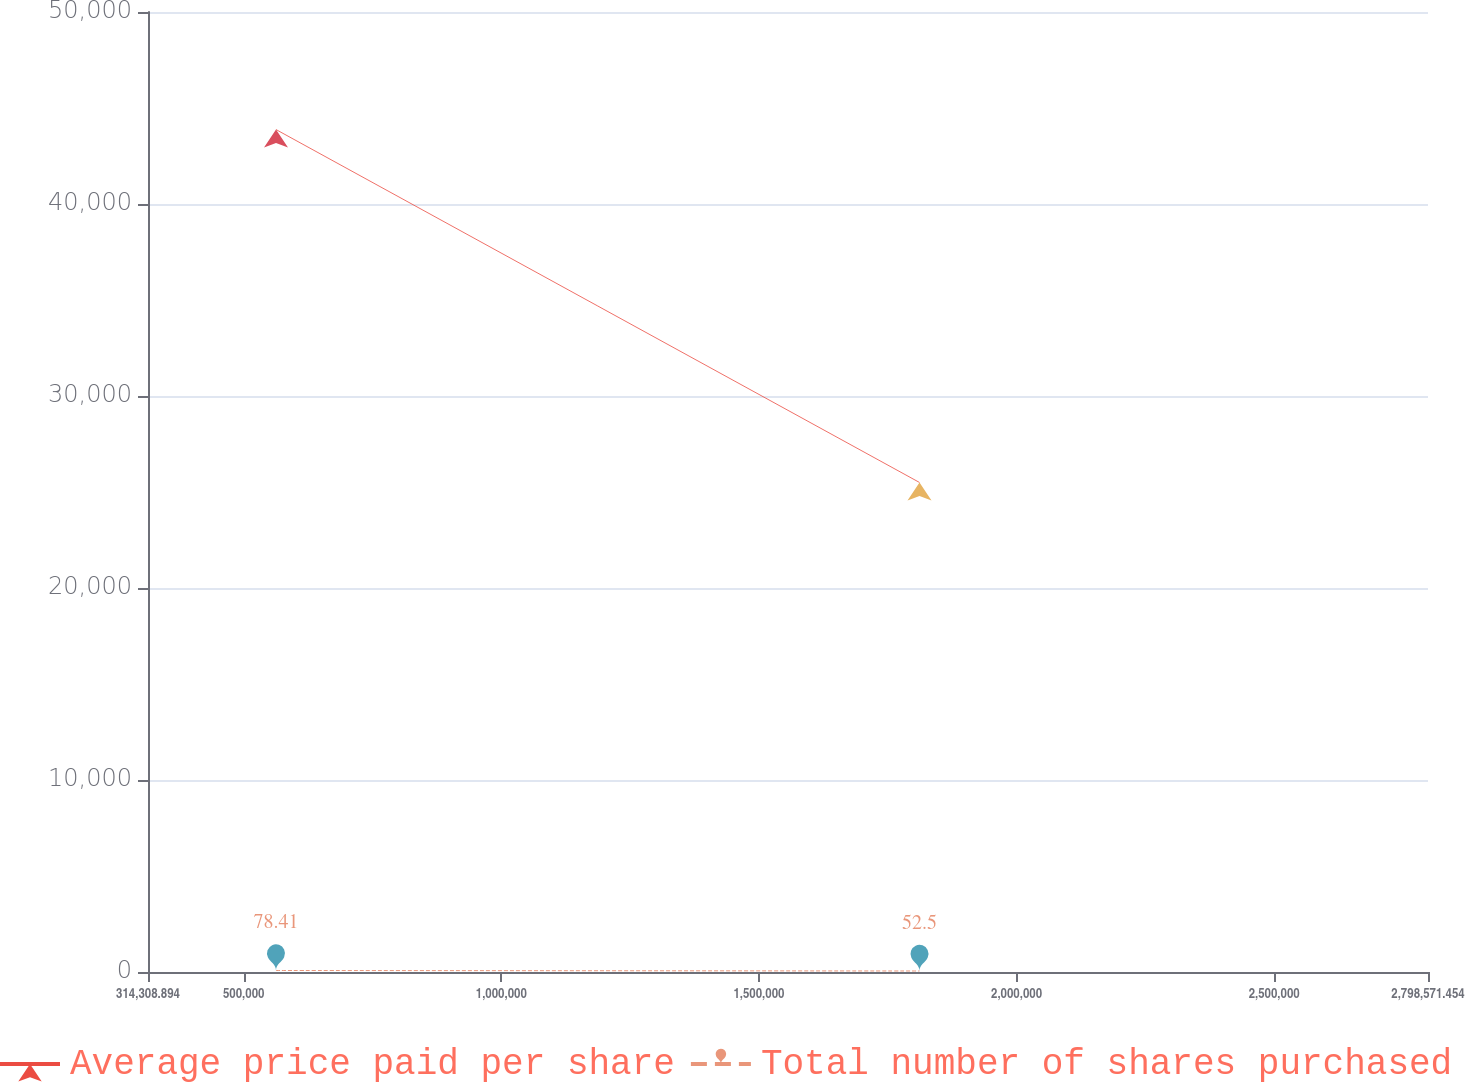Convert chart to OTSL. <chart><loc_0><loc_0><loc_500><loc_500><line_chart><ecel><fcel>Average price paid per share<fcel>Total number of shares purchased<nl><fcel>562735<fcel>43877.6<fcel>78.41<nl><fcel>1.81167e+06<fcel>25495.8<fcel>52.5<nl><fcel>3.047e+06<fcel>9080.7<fcel>55.09<nl></chart> 